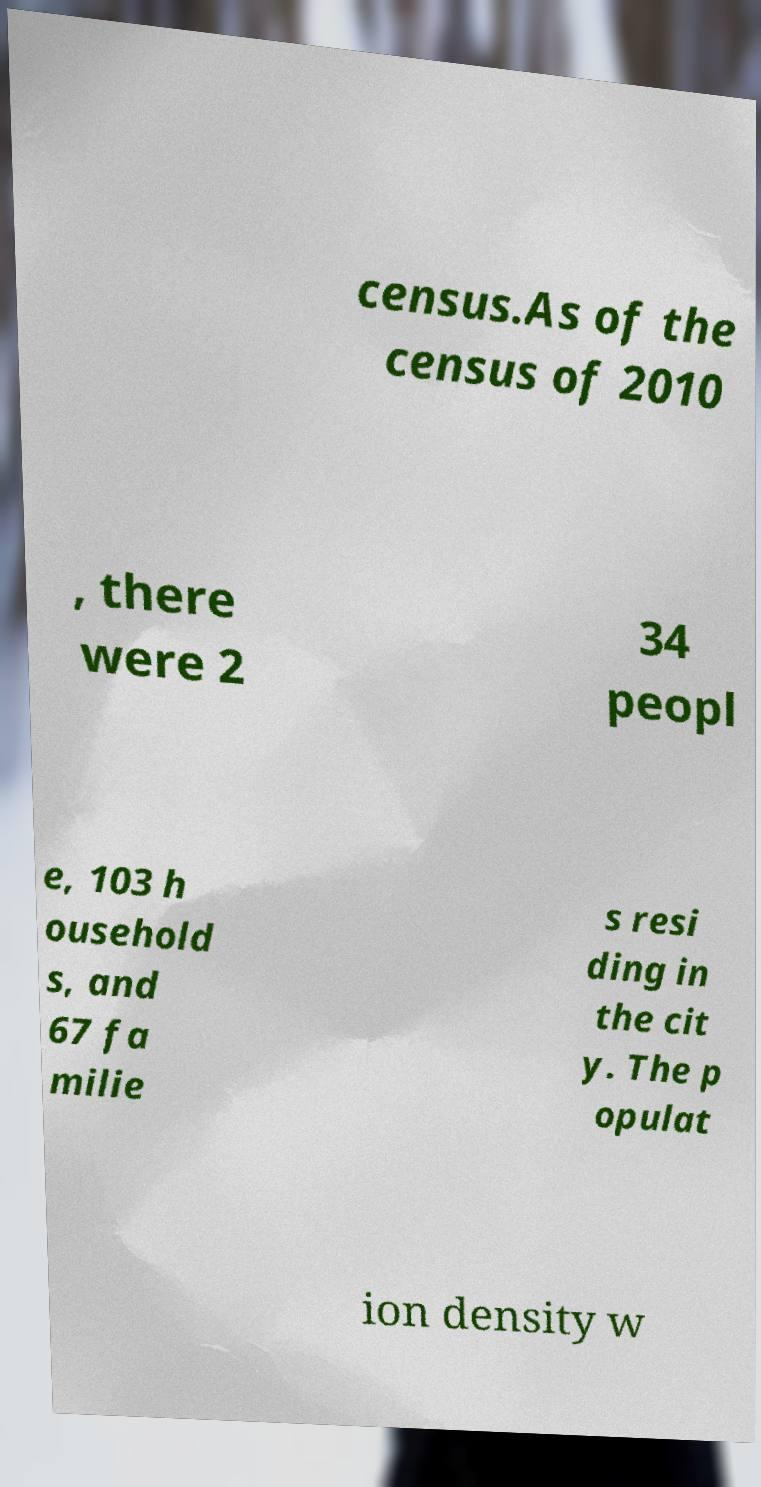Could you extract and type out the text from this image? census.As of the census of 2010 , there were 2 34 peopl e, 103 h ousehold s, and 67 fa milie s resi ding in the cit y. The p opulat ion density w 